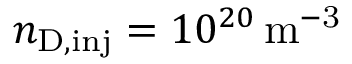<formula> <loc_0><loc_0><loc_500><loc_500>n _ { D , i n j } = 1 0 ^ { 2 0 } \, m ^ { - 3 }</formula> 